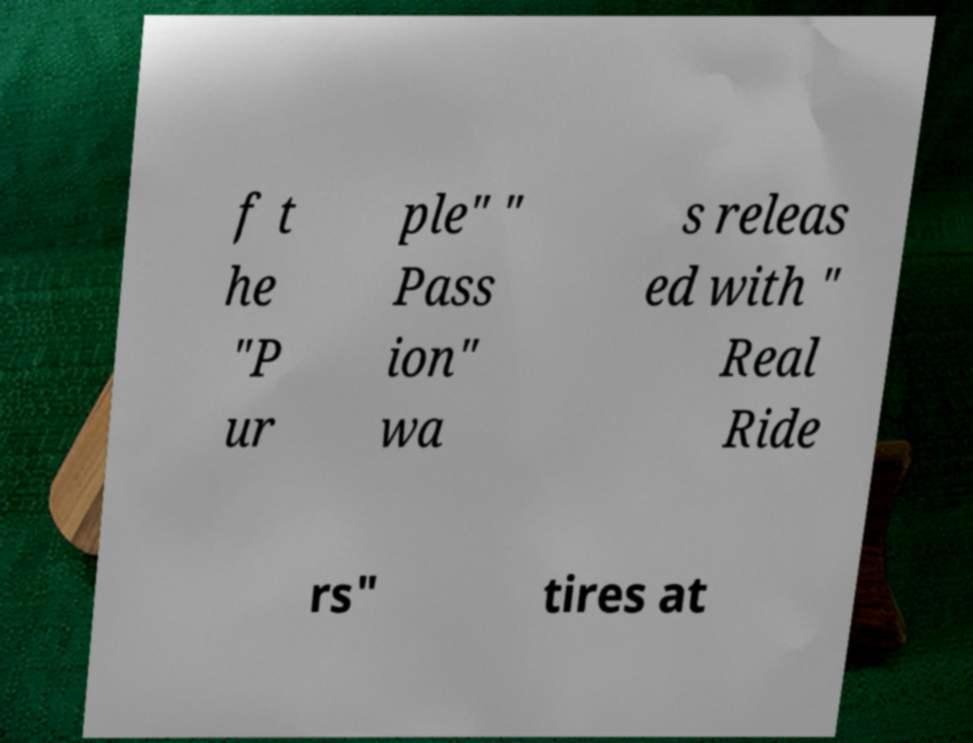There's text embedded in this image that I need extracted. Can you transcribe it verbatim? f t he "P ur ple" " Pass ion" wa s releas ed with " Real Ride rs" tires at 